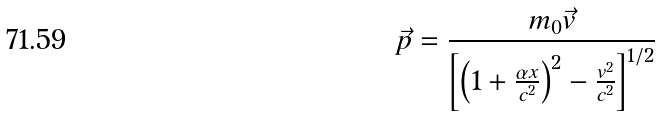<formula> <loc_0><loc_0><loc_500><loc_500>\vec { p } = \frac { m _ { 0 } \vec { v } } { \left [ \left ( 1 + \frac { \alpha x } { c ^ { 2 } } \right ) ^ { 2 } - \frac { v ^ { 2 } } { c ^ { 2 } } \right ] ^ { 1 / 2 } }</formula> 